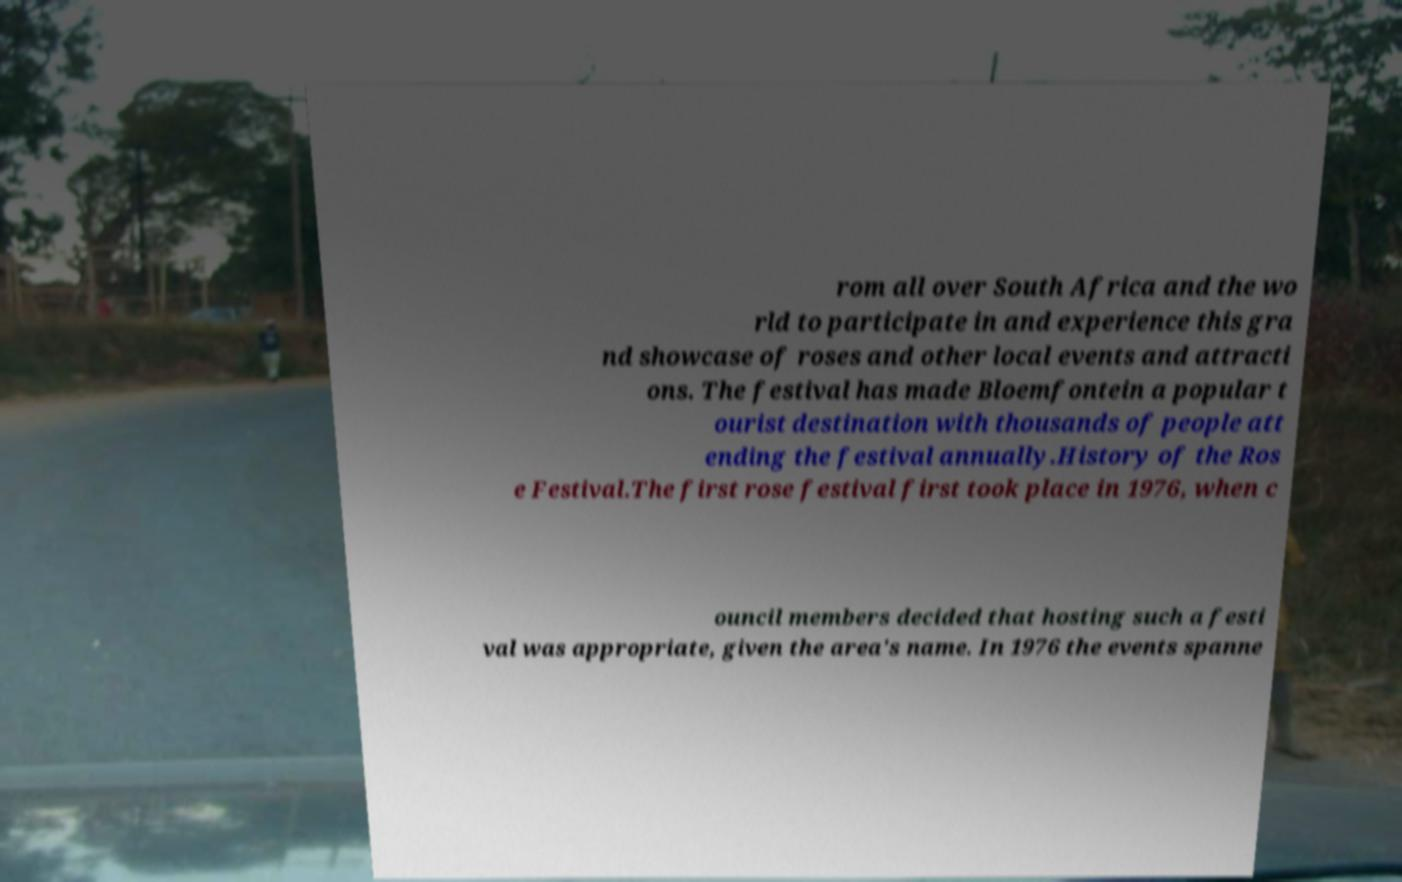What messages or text are displayed in this image? I need them in a readable, typed format. rom all over South Africa and the wo rld to participate in and experience this gra nd showcase of roses and other local events and attracti ons. The festival has made Bloemfontein a popular t ourist destination with thousands of people att ending the festival annually.History of the Ros e Festival.The first rose festival first took place in 1976, when c ouncil members decided that hosting such a festi val was appropriate, given the area's name. In 1976 the events spanne 